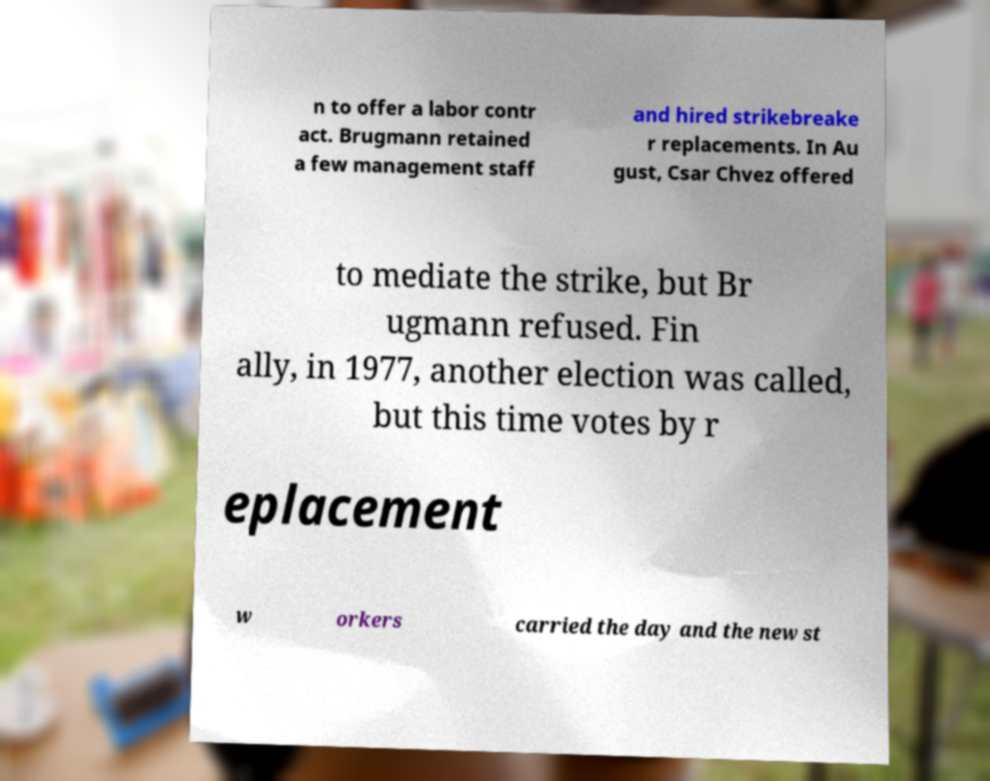Could you assist in decoding the text presented in this image and type it out clearly? n to offer a labor contr act. Brugmann retained a few management staff and hired strikebreake r replacements. In Au gust, Csar Chvez offered to mediate the strike, but Br ugmann refused. Fin ally, in 1977, another election was called, but this time votes by r eplacement w orkers carried the day and the new st 